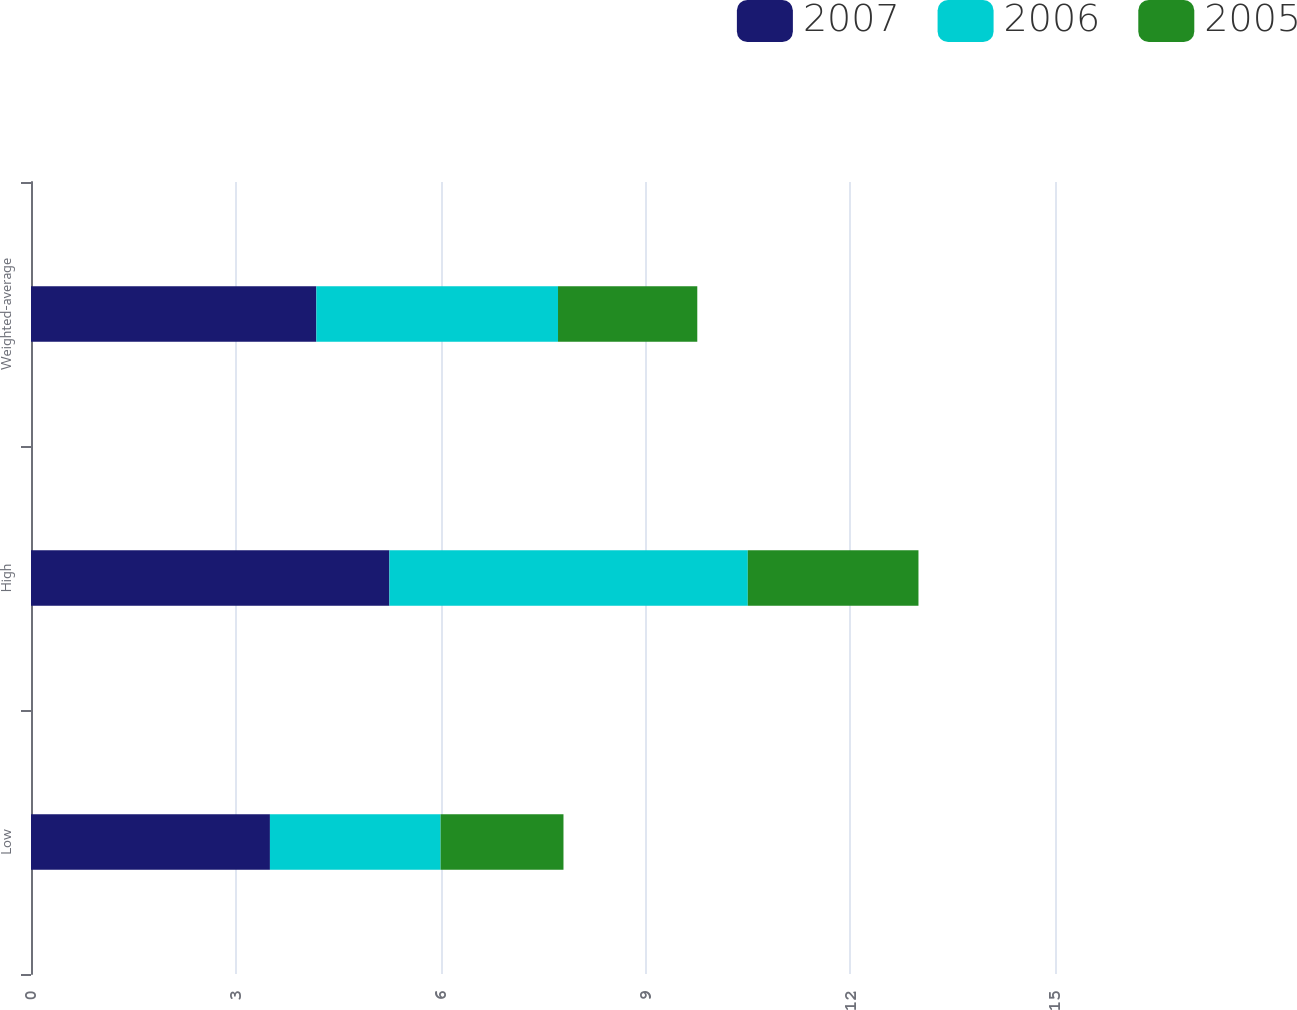<chart> <loc_0><loc_0><loc_500><loc_500><stacked_bar_chart><ecel><fcel>Low<fcel>High<fcel>Weighted-average<nl><fcel>2007<fcel>3.5<fcel>5.25<fcel>4.18<nl><fcel>2006<fcel>2.5<fcel>5.25<fcel>3.54<nl><fcel>2005<fcel>1.8<fcel>2.5<fcel>2.04<nl></chart> 